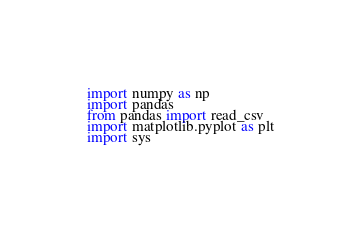Convert code to text. <code><loc_0><loc_0><loc_500><loc_500><_Python_>import numpy as np
import pandas
from pandas import read_csv
import matplotlib.pyplot as plt
import sys
</code> 